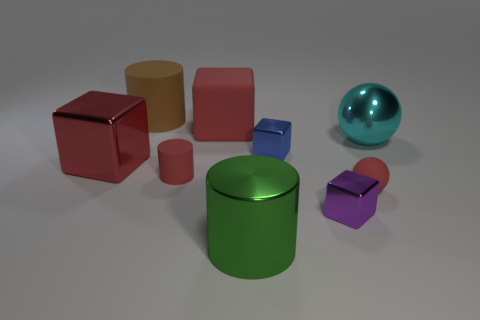What size is the metal block to the left of the big red rubber block?
Provide a succinct answer. Large. Is the small rubber ball the same color as the big matte cylinder?
Provide a succinct answer. No. Is there any other thing that is the same shape as the large brown thing?
Keep it short and to the point. Yes. There is a cylinder that is the same color as the small matte ball; what material is it?
Your answer should be very brief. Rubber. Is the number of green things on the left side of the purple metallic block the same as the number of large brown rubber objects?
Ensure brevity in your answer.  Yes. There is a cyan object; are there any large brown objects behind it?
Ensure brevity in your answer.  Yes. Do the large red metallic thing and the big red thing that is behind the cyan object have the same shape?
Provide a succinct answer. Yes. There is a large cylinder that is made of the same material as the small red ball; what is its color?
Offer a terse response. Brown. The big shiny ball is what color?
Keep it short and to the point. Cyan. Is the small blue block made of the same material as the big cylinder that is behind the red rubber cylinder?
Give a very brief answer. No. 